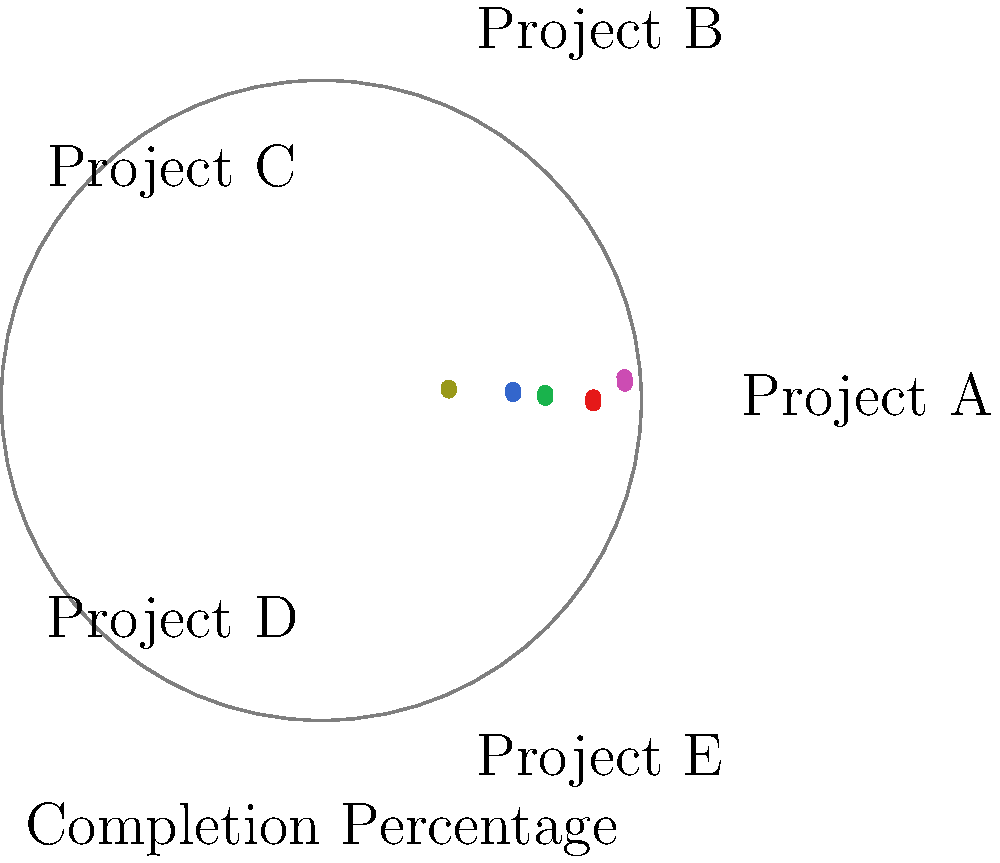As a business consultant specializing in process optimization, you're presenting a radial chart to the club president showing project completion percentages. Which project has the highest completion percentage, and what strategy would you recommend to improve the performance of the least completed project? To answer this question, we need to analyze the radial chart:

1. Identify the projects and their completion percentages:
   - Project A: approximately 85%
   - Project B: approximately 70%
   - Project C: approximately 60%
   - Project D: approximately 95%
   - Project E: approximately 40%

2. Determine the highest completion percentage:
   Project D has the highest completion at 95%.

3. Identify the least completed project:
   Project E has the lowest completion at 40%.

4. Recommend a strategy to improve the performance of Project E:
   As a process optimization specialist, you could suggest:
   a) Conduct a root cause analysis to identify bottlenecks
   b) Implement Lean or Six Sigma methodologies to streamline processes
   c) Reallocate resources from high-performing projects to support Project E
   d) Set up more frequent milestone reviews to track progress and address issues promptly
   e) Provide additional training or support to the team working on Project E

The answer should include both the highest completed project and a concise strategy recommendation.
Answer: Project D (95%); Conduct root cause analysis, implement Lean/Six Sigma, reallocate resources, increase milestone reviews, and provide additional team support for Project E. 